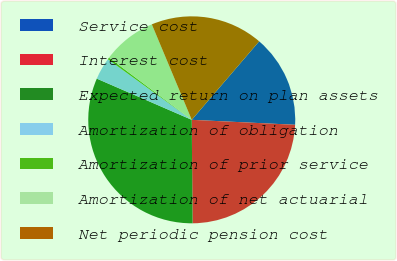<chart> <loc_0><loc_0><loc_500><loc_500><pie_chart><fcel>Service cost<fcel>Interest cost<fcel>Expected return on plan assets<fcel>Amortization of obligation<fcel>Amortization of prior service<fcel>Amortization of net actuarial<fcel>Net periodic pension cost<nl><fcel>14.47%<fcel>24.11%<fcel>31.65%<fcel>3.44%<fcel>0.3%<fcel>8.44%<fcel>17.6%<nl></chart> 